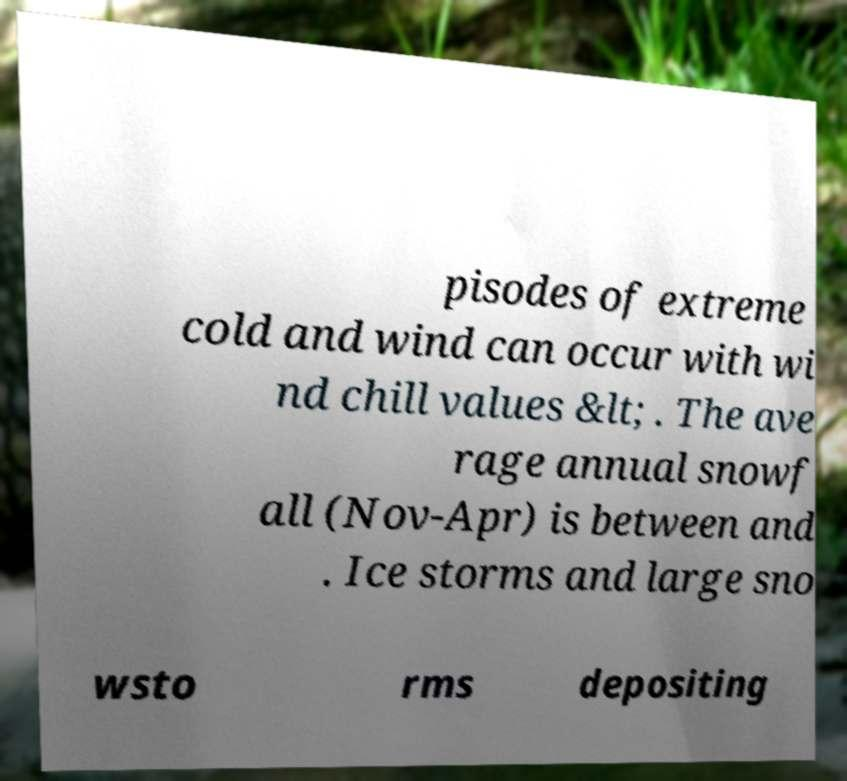Can you read and provide the text displayed in the image?This photo seems to have some interesting text. Can you extract and type it out for me? pisodes of extreme cold and wind can occur with wi nd chill values &lt; . The ave rage annual snowf all (Nov-Apr) is between and . Ice storms and large sno wsto rms depositing 